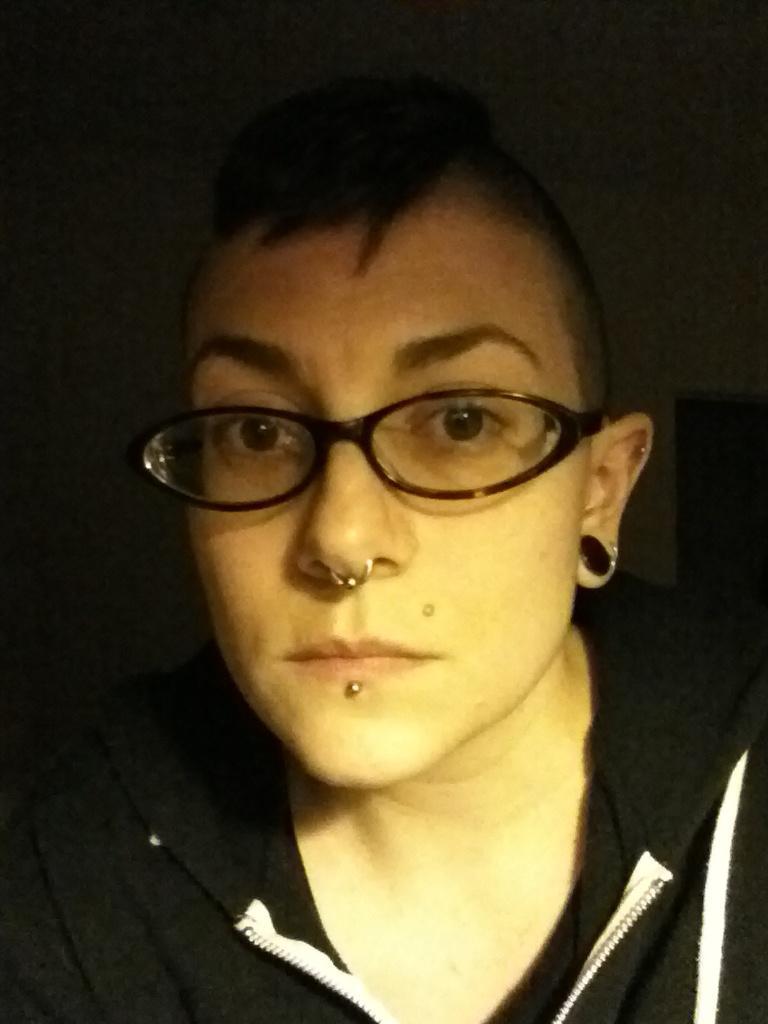How would you summarize this image in a sentence or two? In this image, I can see a person with a nose ring, spectacles, earring and clothes. There is a dark background. 